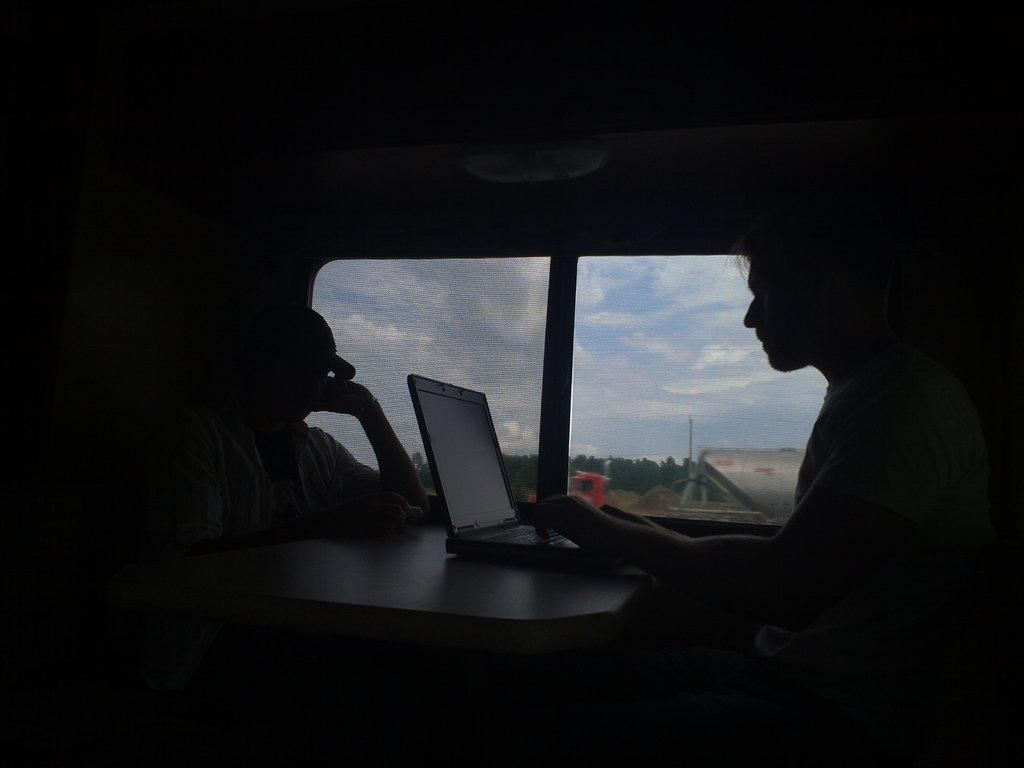What are the people in the image doing? The people in the image are sitting. What electronic device is on the table in the image? There is a laptop on a table in the image. What can be seen in the background of the image? There are windows in the background of the image, and trees are visible through them. What else can be seen through the windows in the background? There are other unspecified objects visible through the windows in the background. What type of scissors are being used by the people in the image? There are no scissors visible in the image. What authority figure is present in the image? There is no authority figure present in the image. 